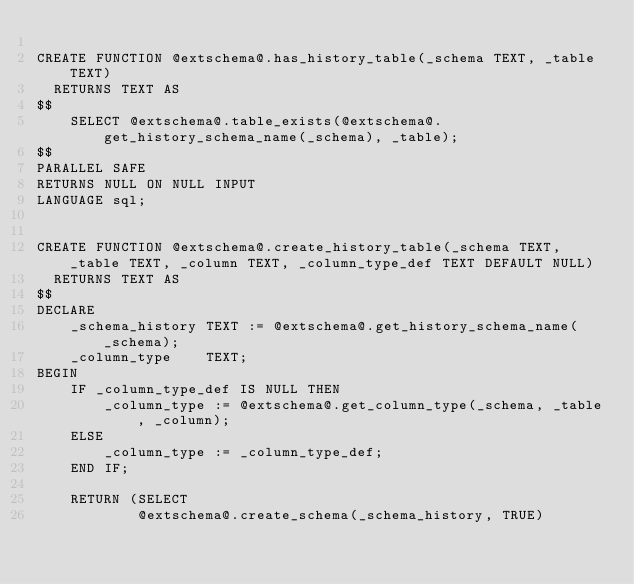Convert code to text. <code><loc_0><loc_0><loc_500><loc_500><_SQL_>
CREATE FUNCTION @extschema@.has_history_table(_schema TEXT, _table TEXT)
  RETURNS TEXT AS
$$
	SELECT @extschema@.table_exists(@extschema@.get_history_schema_name(_schema), _table);
$$
PARALLEL SAFE
RETURNS NULL ON NULL INPUT
LANGUAGE sql;


CREATE FUNCTION @extschema@.create_history_table(_schema TEXT, _table TEXT, _column TEXT, _column_type_def TEXT DEFAULT NULL)
  RETURNS TEXT AS
$$
DECLARE
	_schema_history TEXT := @extschema@.get_history_schema_name(_schema);
	_column_type	TEXT;
BEGIN
	IF _column_type_def IS NULL THEN
		_column_type := @extschema@.get_column_type(_schema, _table, _column);
	ELSE
		_column_type := _column_type_def;
	END IF;
	
	RETURN (SELECT 
			@extschema@.create_schema(_schema_history, TRUE)</code> 